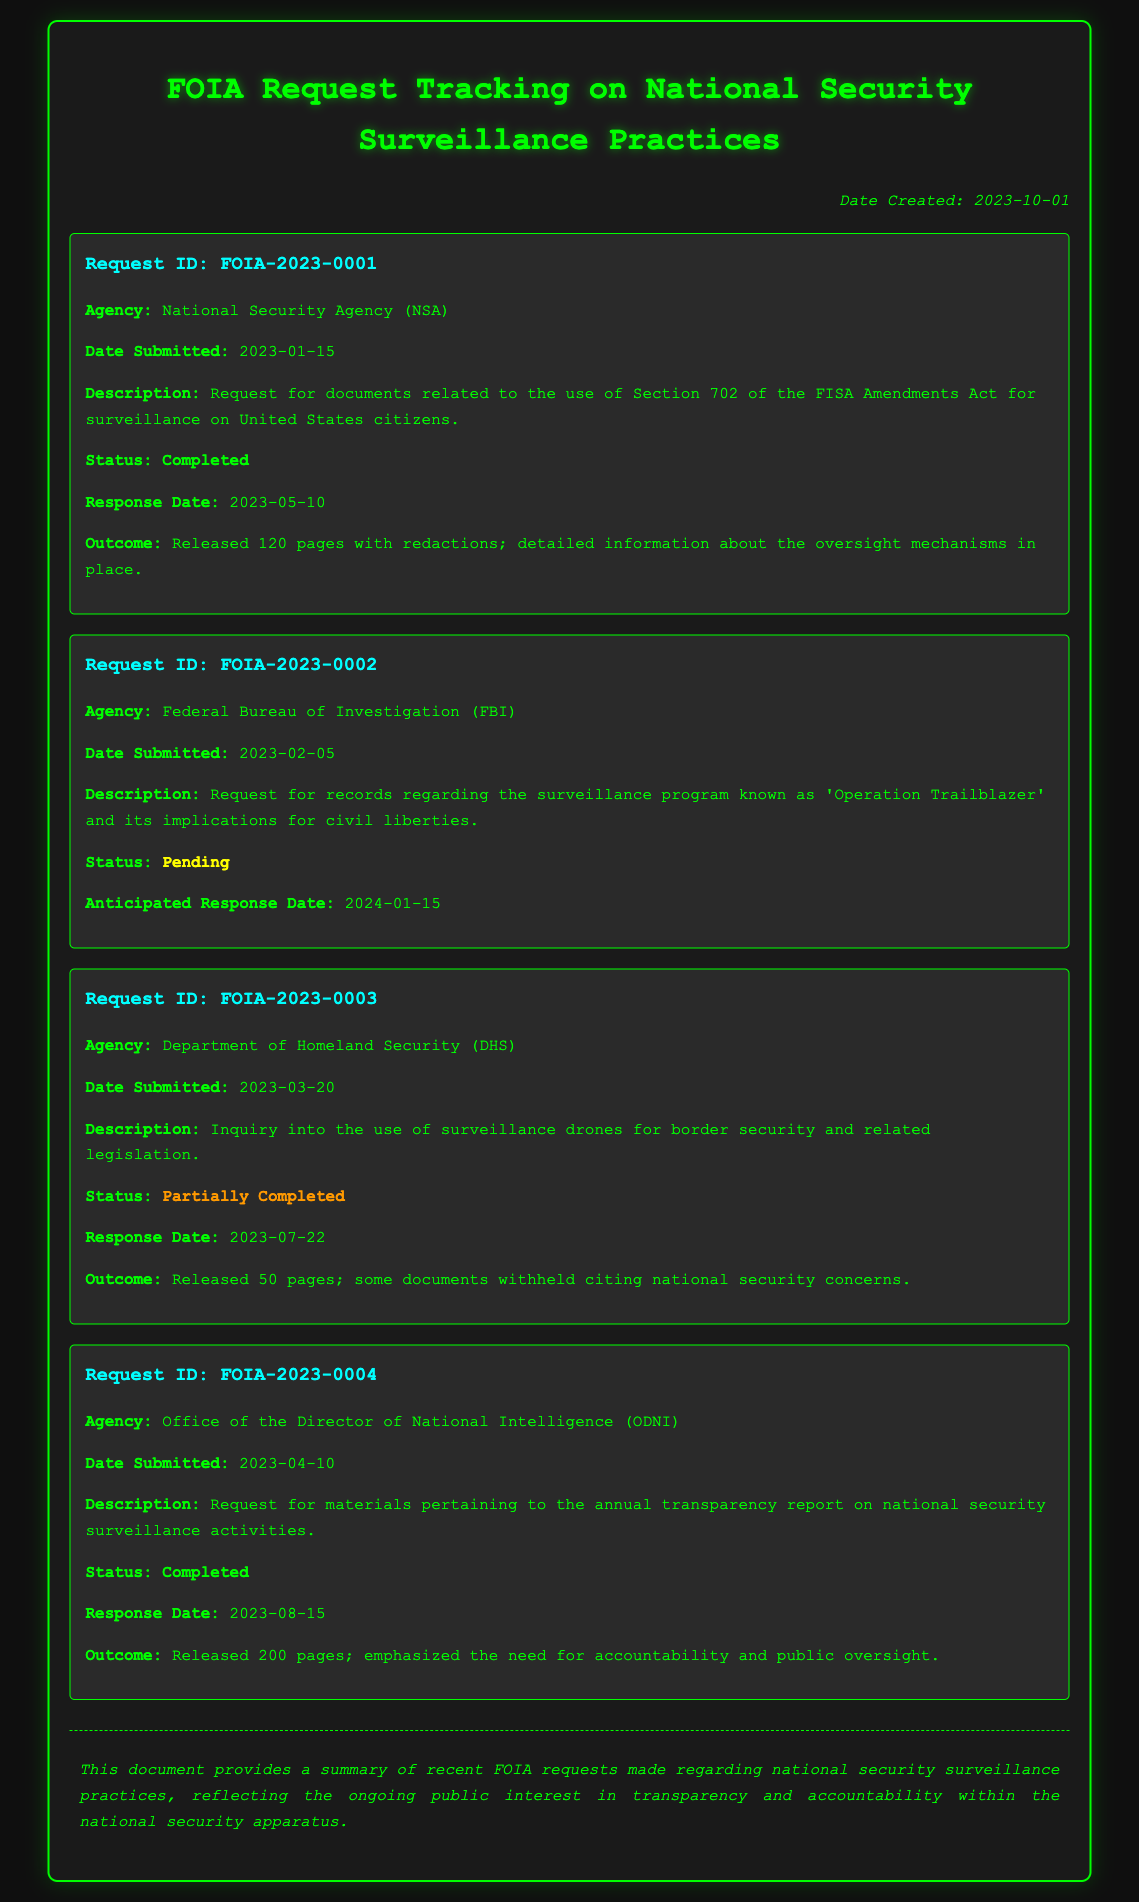What is the first request ID listed? The first request ID shown in the document is highlighted in the first request section.
Answer: FOIA-2023-0001 Which agency is responsible for the second request? The second request is associated with a specific agency, mentioned in that request section.
Answer: Federal Bureau of Investigation (FBI) On what date was the request for the transparency report submitted? The submission date for the request regarding the annual transparency report is specified in the respective request.
Answer: 2023-04-10 How many pages were released in the completed request for Section 702 documents? The total number of pages released for the first completed request is clearly stated in the outcome section of that request.
Answer: 120 pages What is the status of the request regarding 'Operation Trailblazer'? The status of that particular request indicates whether it has been completed, is pending, or partially completed.
Answer: Pending How many total pages were released in the request concerning national security surveillance activities? The total page count released in the completed request for materials on national security is provided in the outcome section.
Answer: 200 pages What was the anticipated response date for the second request? The expected response date for that request is directly mentioned in its details.
Answer: 2024-01-15 Which request had a status indicating it was partially completed? The specific request with a partial completion status is identified in the request sections.
Answer: FOIA-2023-0003 What primary theme connects all the FOIA requests in this document? The overarching theme can be derived from the nature of the requests seen throughout the document.
Answer: National security surveillance practices 